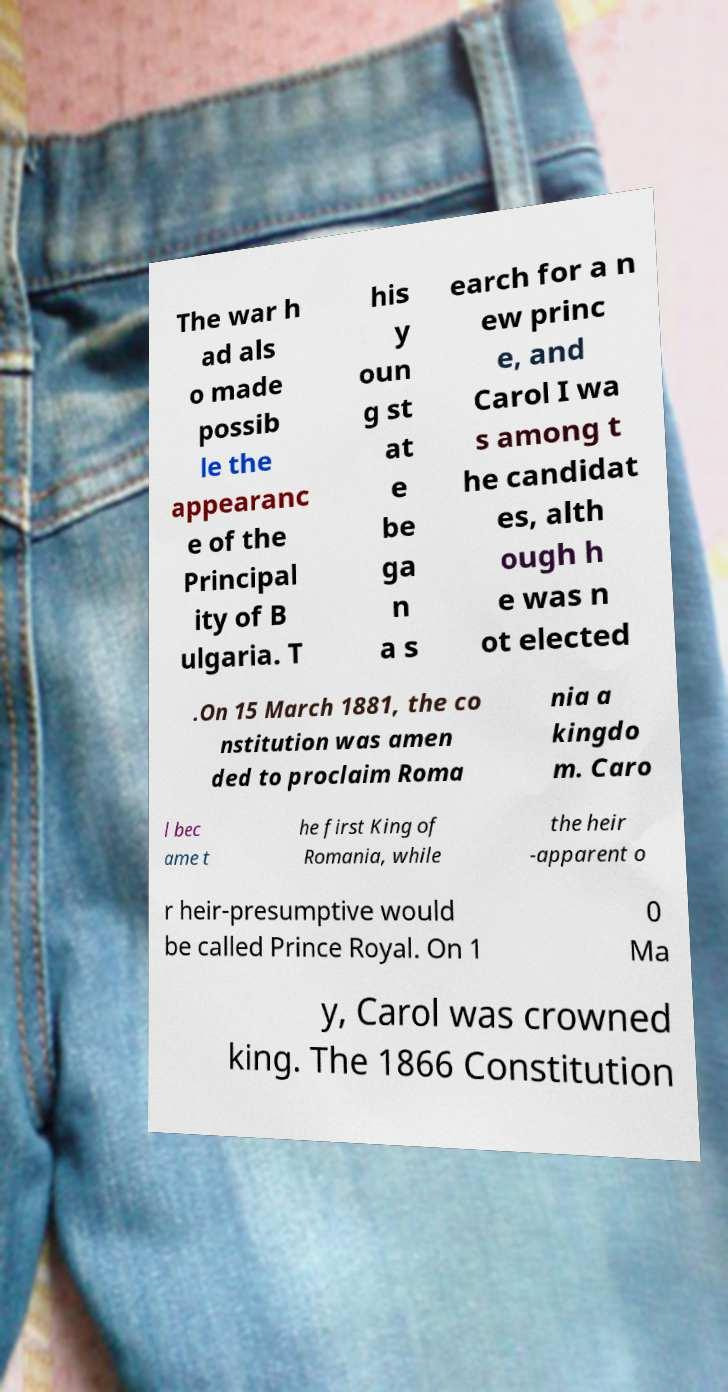Could you extract and type out the text from this image? The war h ad als o made possib le the appearanc e of the Principal ity of B ulgaria. T his y oun g st at e be ga n a s earch for a n ew princ e, and Carol I wa s among t he candidat es, alth ough h e was n ot elected .On 15 March 1881, the co nstitution was amen ded to proclaim Roma nia a kingdo m. Caro l bec ame t he first King of Romania, while the heir -apparent o r heir-presumptive would be called Prince Royal. On 1 0 Ma y, Carol was crowned king. The 1866 Constitution 